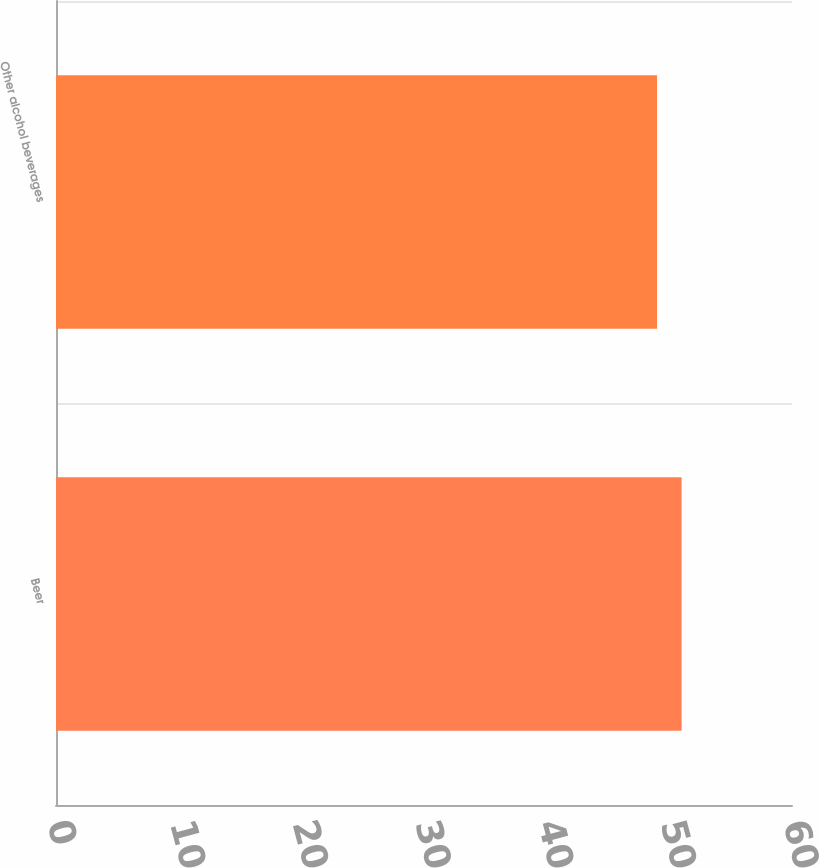Convert chart to OTSL. <chart><loc_0><loc_0><loc_500><loc_500><bar_chart><fcel>Beer<fcel>Other alcohol beverages<nl><fcel>51<fcel>49<nl></chart> 